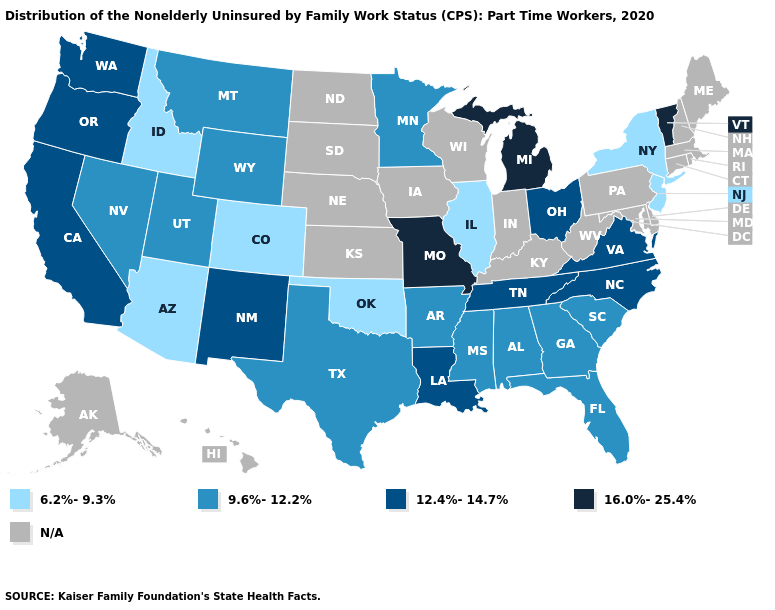Does Colorado have the highest value in the USA?
Short answer required. No. What is the value of Colorado?
Write a very short answer. 6.2%-9.3%. What is the value of Virginia?
Be succinct. 12.4%-14.7%. Name the states that have a value in the range 6.2%-9.3%?
Answer briefly. Arizona, Colorado, Idaho, Illinois, New Jersey, New York, Oklahoma. Name the states that have a value in the range 16.0%-25.4%?
Write a very short answer. Michigan, Missouri, Vermont. What is the value of California?
Write a very short answer. 12.4%-14.7%. How many symbols are there in the legend?
Write a very short answer. 5. Which states have the lowest value in the Northeast?
Give a very brief answer. New Jersey, New York. What is the value of Kansas?
Concise answer only. N/A. What is the value of Arizona?
Short answer required. 6.2%-9.3%. Among the states that border Georgia , which have the lowest value?
Write a very short answer. Alabama, Florida, South Carolina. What is the lowest value in states that border Pennsylvania?
Write a very short answer. 6.2%-9.3%. What is the lowest value in the Northeast?
Concise answer only. 6.2%-9.3%. What is the value of Massachusetts?
Write a very short answer. N/A. 